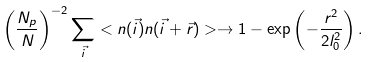Convert formula to latex. <formula><loc_0><loc_0><loc_500><loc_500>\left ( \frac { N _ { p } } { N } \right ) ^ { - 2 } \sum _ { \vec { i } } < n ( \vec { i } ) n ( \vec { i } + \vec { r } ) > \rightarrow 1 - \exp \left ( - \frac { r ^ { 2 } } { 2 l _ { 0 } ^ { 2 } } \right ) .</formula> 